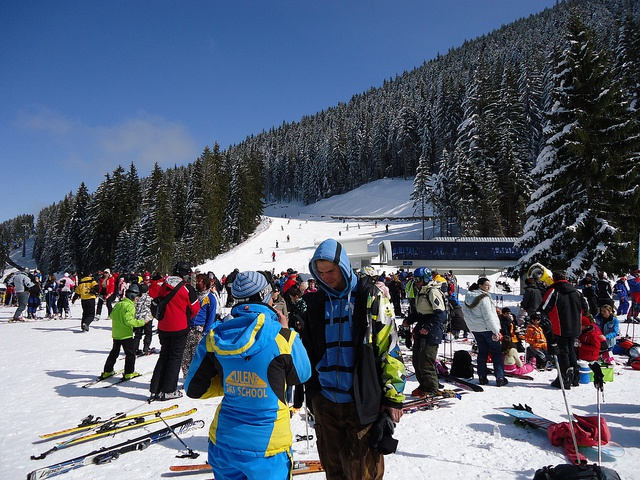Describe the objects in this image and their specific colors. I can see people in darkblue, black, white, gray, and maroon tones, people in darkblue, black, navy, lightgray, and maroon tones, people in darkblue, blue, black, gray, and navy tones, bus in darkblue, black, gray, lightgray, and darkgray tones, and people in darkblue, black, gray, lightgray, and navy tones in this image. 